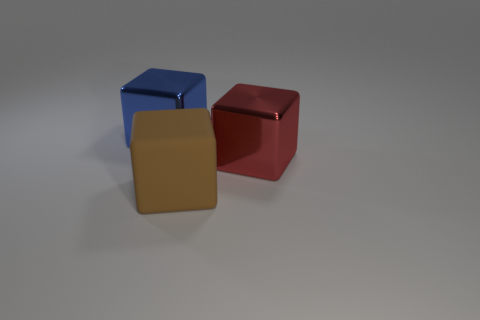Add 3 brown blocks. How many objects exist? 6 Add 3 tiny red rubber cylinders. How many tiny red rubber cylinders exist? 3 Subtract 0 cyan cubes. How many objects are left? 3 Subtract all matte cubes. Subtract all metal objects. How many objects are left? 0 Add 1 big red shiny things. How many big red shiny things are left? 2 